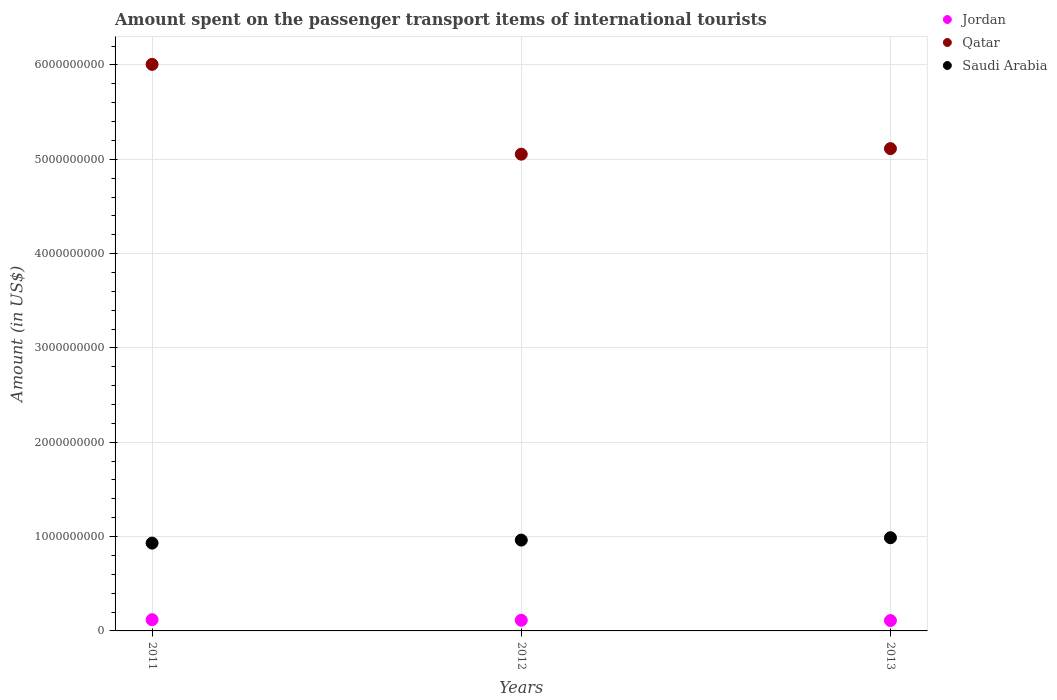Is the number of dotlines equal to the number of legend labels?
Your answer should be compact. Yes. What is the amount spent on the passenger transport items of international tourists in Jordan in 2011?
Offer a very short reply. 1.19e+08. Across all years, what is the maximum amount spent on the passenger transport items of international tourists in Jordan?
Provide a short and direct response. 1.19e+08. Across all years, what is the minimum amount spent on the passenger transport items of international tourists in Jordan?
Provide a succinct answer. 1.10e+08. In which year was the amount spent on the passenger transport items of international tourists in Jordan minimum?
Give a very brief answer. 2013. What is the total amount spent on the passenger transport items of international tourists in Qatar in the graph?
Keep it short and to the point. 1.62e+1. What is the difference between the amount spent on the passenger transport items of international tourists in Saudi Arabia in 2011 and that in 2013?
Make the answer very short. -5.70e+07. What is the difference between the amount spent on the passenger transport items of international tourists in Qatar in 2011 and the amount spent on the passenger transport items of international tourists in Saudi Arabia in 2012?
Your answer should be very brief. 5.04e+09. What is the average amount spent on the passenger transport items of international tourists in Saudi Arabia per year?
Provide a short and direct response. 9.61e+08. In the year 2012, what is the difference between the amount spent on the passenger transport items of international tourists in Jordan and amount spent on the passenger transport items of international tourists in Qatar?
Provide a short and direct response. -4.94e+09. What is the ratio of the amount spent on the passenger transport items of international tourists in Qatar in 2012 to that in 2013?
Your answer should be very brief. 0.99. Is the amount spent on the passenger transport items of international tourists in Qatar in 2011 less than that in 2012?
Provide a short and direct response. No. What is the difference between the highest and the second highest amount spent on the passenger transport items of international tourists in Saudi Arabia?
Your answer should be compact. 2.50e+07. What is the difference between the highest and the lowest amount spent on the passenger transport items of international tourists in Saudi Arabia?
Your answer should be very brief. 5.70e+07. In how many years, is the amount spent on the passenger transport items of international tourists in Saudi Arabia greater than the average amount spent on the passenger transport items of international tourists in Saudi Arabia taken over all years?
Ensure brevity in your answer.  2. Is the sum of the amount spent on the passenger transport items of international tourists in Saudi Arabia in 2011 and 2012 greater than the maximum amount spent on the passenger transport items of international tourists in Qatar across all years?
Offer a terse response. No. Is it the case that in every year, the sum of the amount spent on the passenger transport items of international tourists in Qatar and amount spent on the passenger transport items of international tourists in Jordan  is greater than the amount spent on the passenger transport items of international tourists in Saudi Arabia?
Your answer should be very brief. Yes. Is the amount spent on the passenger transport items of international tourists in Jordan strictly less than the amount spent on the passenger transport items of international tourists in Qatar over the years?
Keep it short and to the point. Yes. How many dotlines are there?
Ensure brevity in your answer.  3. How many years are there in the graph?
Provide a succinct answer. 3. Does the graph contain any zero values?
Your response must be concise. No. Does the graph contain grids?
Keep it short and to the point. Yes. Where does the legend appear in the graph?
Offer a terse response. Top right. How many legend labels are there?
Give a very brief answer. 3. How are the legend labels stacked?
Provide a short and direct response. Vertical. What is the title of the graph?
Ensure brevity in your answer.  Amount spent on the passenger transport items of international tourists. What is the Amount (in US$) in Jordan in 2011?
Provide a succinct answer. 1.19e+08. What is the Amount (in US$) of Qatar in 2011?
Your answer should be very brief. 6.01e+09. What is the Amount (in US$) of Saudi Arabia in 2011?
Provide a succinct answer. 9.31e+08. What is the Amount (in US$) of Jordan in 2012?
Offer a very short reply. 1.13e+08. What is the Amount (in US$) in Qatar in 2012?
Your response must be concise. 5.05e+09. What is the Amount (in US$) in Saudi Arabia in 2012?
Provide a short and direct response. 9.63e+08. What is the Amount (in US$) in Jordan in 2013?
Offer a very short reply. 1.10e+08. What is the Amount (in US$) of Qatar in 2013?
Give a very brief answer. 5.11e+09. What is the Amount (in US$) in Saudi Arabia in 2013?
Ensure brevity in your answer.  9.88e+08. Across all years, what is the maximum Amount (in US$) of Jordan?
Keep it short and to the point. 1.19e+08. Across all years, what is the maximum Amount (in US$) in Qatar?
Your response must be concise. 6.01e+09. Across all years, what is the maximum Amount (in US$) in Saudi Arabia?
Give a very brief answer. 9.88e+08. Across all years, what is the minimum Amount (in US$) of Jordan?
Keep it short and to the point. 1.10e+08. Across all years, what is the minimum Amount (in US$) of Qatar?
Keep it short and to the point. 5.05e+09. Across all years, what is the minimum Amount (in US$) of Saudi Arabia?
Give a very brief answer. 9.31e+08. What is the total Amount (in US$) in Jordan in the graph?
Keep it short and to the point. 3.42e+08. What is the total Amount (in US$) of Qatar in the graph?
Your answer should be compact. 1.62e+1. What is the total Amount (in US$) of Saudi Arabia in the graph?
Ensure brevity in your answer.  2.88e+09. What is the difference between the Amount (in US$) in Qatar in 2011 and that in 2012?
Give a very brief answer. 9.52e+08. What is the difference between the Amount (in US$) in Saudi Arabia in 2011 and that in 2012?
Your answer should be compact. -3.20e+07. What is the difference between the Amount (in US$) of Jordan in 2011 and that in 2013?
Your response must be concise. 9.00e+06. What is the difference between the Amount (in US$) in Qatar in 2011 and that in 2013?
Offer a terse response. 8.93e+08. What is the difference between the Amount (in US$) of Saudi Arabia in 2011 and that in 2013?
Keep it short and to the point. -5.70e+07. What is the difference between the Amount (in US$) of Jordan in 2012 and that in 2013?
Your answer should be compact. 3.00e+06. What is the difference between the Amount (in US$) in Qatar in 2012 and that in 2013?
Your response must be concise. -5.90e+07. What is the difference between the Amount (in US$) of Saudi Arabia in 2012 and that in 2013?
Your answer should be compact. -2.50e+07. What is the difference between the Amount (in US$) in Jordan in 2011 and the Amount (in US$) in Qatar in 2012?
Make the answer very short. -4.94e+09. What is the difference between the Amount (in US$) in Jordan in 2011 and the Amount (in US$) in Saudi Arabia in 2012?
Keep it short and to the point. -8.44e+08. What is the difference between the Amount (in US$) in Qatar in 2011 and the Amount (in US$) in Saudi Arabia in 2012?
Give a very brief answer. 5.04e+09. What is the difference between the Amount (in US$) of Jordan in 2011 and the Amount (in US$) of Qatar in 2013?
Your answer should be compact. -4.99e+09. What is the difference between the Amount (in US$) in Jordan in 2011 and the Amount (in US$) in Saudi Arabia in 2013?
Offer a very short reply. -8.69e+08. What is the difference between the Amount (in US$) in Qatar in 2011 and the Amount (in US$) in Saudi Arabia in 2013?
Offer a terse response. 5.02e+09. What is the difference between the Amount (in US$) in Jordan in 2012 and the Amount (in US$) in Qatar in 2013?
Make the answer very short. -5.00e+09. What is the difference between the Amount (in US$) in Jordan in 2012 and the Amount (in US$) in Saudi Arabia in 2013?
Your response must be concise. -8.75e+08. What is the difference between the Amount (in US$) in Qatar in 2012 and the Amount (in US$) in Saudi Arabia in 2013?
Make the answer very short. 4.07e+09. What is the average Amount (in US$) in Jordan per year?
Offer a terse response. 1.14e+08. What is the average Amount (in US$) of Qatar per year?
Give a very brief answer. 5.39e+09. What is the average Amount (in US$) of Saudi Arabia per year?
Your answer should be compact. 9.61e+08. In the year 2011, what is the difference between the Amount (in US$) of Jordan and Amount (in US$) of Qatar?
Make the answer very short. -5.89e+09. In the year 2011, what is the difference between the Amount (in US$) of Jordan and Amount (in US$) of Saudi Arabia?
Your response must be concise. -8.12e+08. In the year 2011, what is the difference between the Amount (in US$) in Qatar and Amount (in US$) in Saudi Arabia?
Your answer should be very brief. 5.08e+09. In the year 2012, what is the difference between the Amount (in US$) in Jordan and Amount (in US$) in Qatar?
Keep it short and to the point. -4.94e+09. In the year 2012, what is the difference between the Amount (in US$) of Jordan and Amount (in US$) of Saudi Arabia?
Keep it short and to the point. -8.50e+08. In the year 2012, what is the difference between the Amount (in US$) of Qatar and Amount (in US$) of Saudi Arabia?
Your answer should be compact. 4.09e+09. In the year 2013, what is the difference between the Amount (in US$) of Jordan and Amount (in US$) of Qatar?
Ensure brevity in your answer.  -5.00e+09. In the year 2013, what is the difference between the Amount (in US$) of Jordan and Amount (in US$) of Saudi Arabia?
Your response must be concise. -8.78e+08. In the year 2013, what is the difference between the Amount (in US$) of Qatar and Amount (in US$) of Saudi Arabia?
Keep it short and to the point. 4.12e+09. What is the ratio of the Amount (in US$) of Jordan in 2011 to that in 2012?
Your answer should be compact. 1.05. What is the ratio of the Amount (in US$) of Qatar in 2011 to that in 2012?
Make the answer very short. 1.19. What is the ratio of the Amount (in US$) in Saudi Arabia in 2011 to that in 2012?
Your answer should be compact. 0.97. What is the ratio of the Amount (in US$) of Jordan in 2011 to that in 2013?
Your answer should be compact. 1.08. What is the ratio of the Amount (in US$) of Qatar in 2011 to that in 2013?
Offer a very short reply. 1.17. What is the ratio of the Amount (in US$) in Saudi Arabia in 2011 to that in 2013?
Keep it short and to the point. 0.94. What is the ratio of the Amount (in US$) of Jordan in 2012 to that in 2013?
Your answer should be very brief. 1.03. What is the ratio of the Amount (in US$) of Saudi Arabia in 2012 to that in 2013?
Offer a terse response. 0.97. What is the difference between the highest and the second highest Amount (in US$) of Qatar?
Provide a succinct answer. 8.93e+08. What is the difference between the highest and the second highest Amount (in US$) of Saudi Arabia?
Your answer should be very brief. 2.50e+07. What is the difference between the highest and the lowest Amount (in US$) of Jordan?
Your answer should be very brief. 9.00e+06. What is the difference between the highest and the lowest Amount (in US$) of Qatar?
Provide a succinct answer. 9.52e+08. What is the difference between the highest and the lowest Amount (in US$) of Saudi Arabia?
Provide a short and direct response. 5.70e+07. 